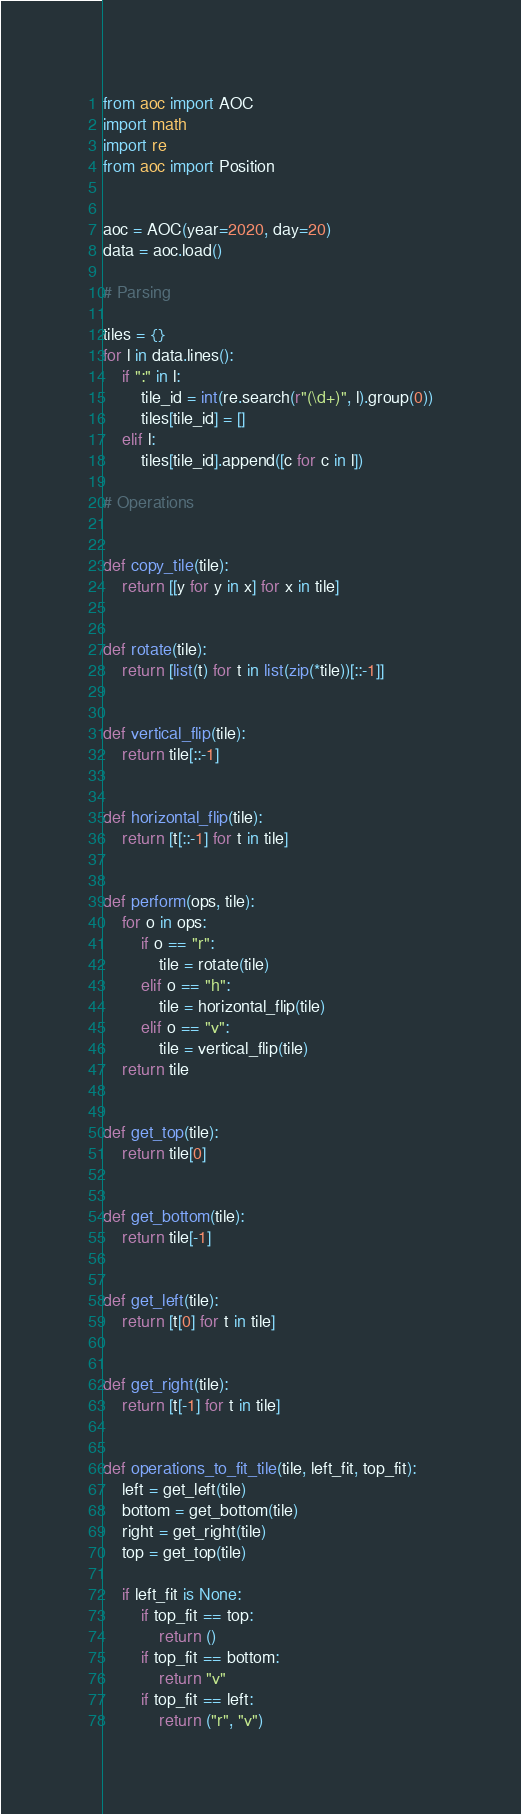<code> <loc_0><loc_0><loc_500><loc_500><_Python_>from aoc import AOC
import math
import re
from aoc import Position


aoc = AOC(year=2020, day=20)
data = aoc.load()

# Parsing

tiles = {}
for l in data.lines():
    if ":" in l:
        tile_id = int(re.search(r"(\d+)", l).group(0))
        tiles[tile_id] = []
    elif l:
        tiles[tile_id].append([c for c in l])

# Operations


def copy_tile(tile):
    return [[y for y in x] for x in tile]


def rotate(tile):
    return [list(t) for t in list(zip(*tile))[::-1]]


def vertical_flip(tile):
    return tile[::-1]


def horizontal_flip(tile):
    return [t[::-1] for t in tile]


def perform(ops, tile):
    for o in ops:
        if o == "r":
            tile = rotate(tile)
        elif o == "h":
            tile = horizontal_flip(tile)
        elif o == "v":
            tile = vertical_flip(tile)
    return tile


def get_top(tile):
    return tile[0]


def get_bottom(tile):
    return tile[-1]


def get_left(tile):
    return [t[0] for t in tile]


def get_right(tile):
    return [t[-1] for t in tile]


def operations_to_fit_tile(tile, left_fit, top_fit):
    left = get_left(tile)
    bottom = get_bottom(tile)
    right = get_right(tile)
    top = get_top(tile)

    if left_fit is None:
        if top_fit == top:
            return ()
        if top_fit == bottom:
            return "v"
        if top_fit == left:
            return ("r", "v")</code> 